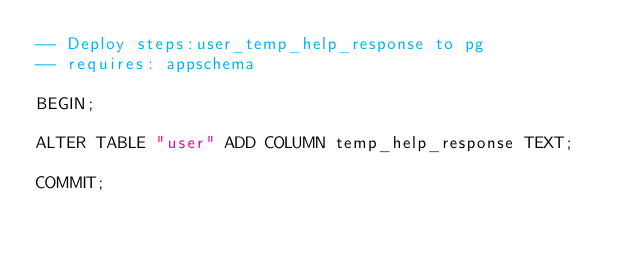Convert code to text. <code><loc_0><loc_0><loc_500><loc_500><_SQL_>-- Deploy steps:user_temp_help_response to pg
-- requires: appschema

BEGIN;

ALTER TABLE "user" ADD COLUMN temp_help_response TEXT;

COMMIT;
</code> 